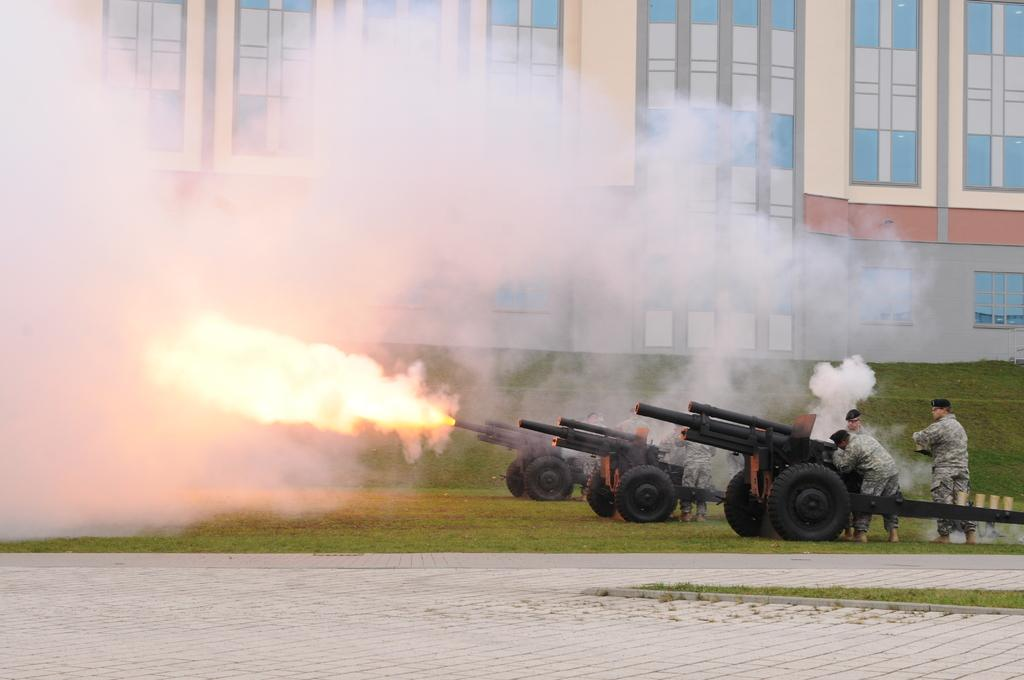What objects are on the ground in the image? There are rifles on the ground in the image. What else can be seen in the image besides the rifles? There are persons standing in the image. What type of structures are visible in the image? There are buildings visible in the image. What surface are the rifles and persons standing on? There is a floor in the image. Can you tell me how many bikes are parked next to the buildings in the image? There are no bikes present in the image; it only features rifles, persons, buildings, and a floor. What type of pan is being used by the persons in the image? There is no pan visible in the image; it only features rifles, persons, buildings, and a floor. 